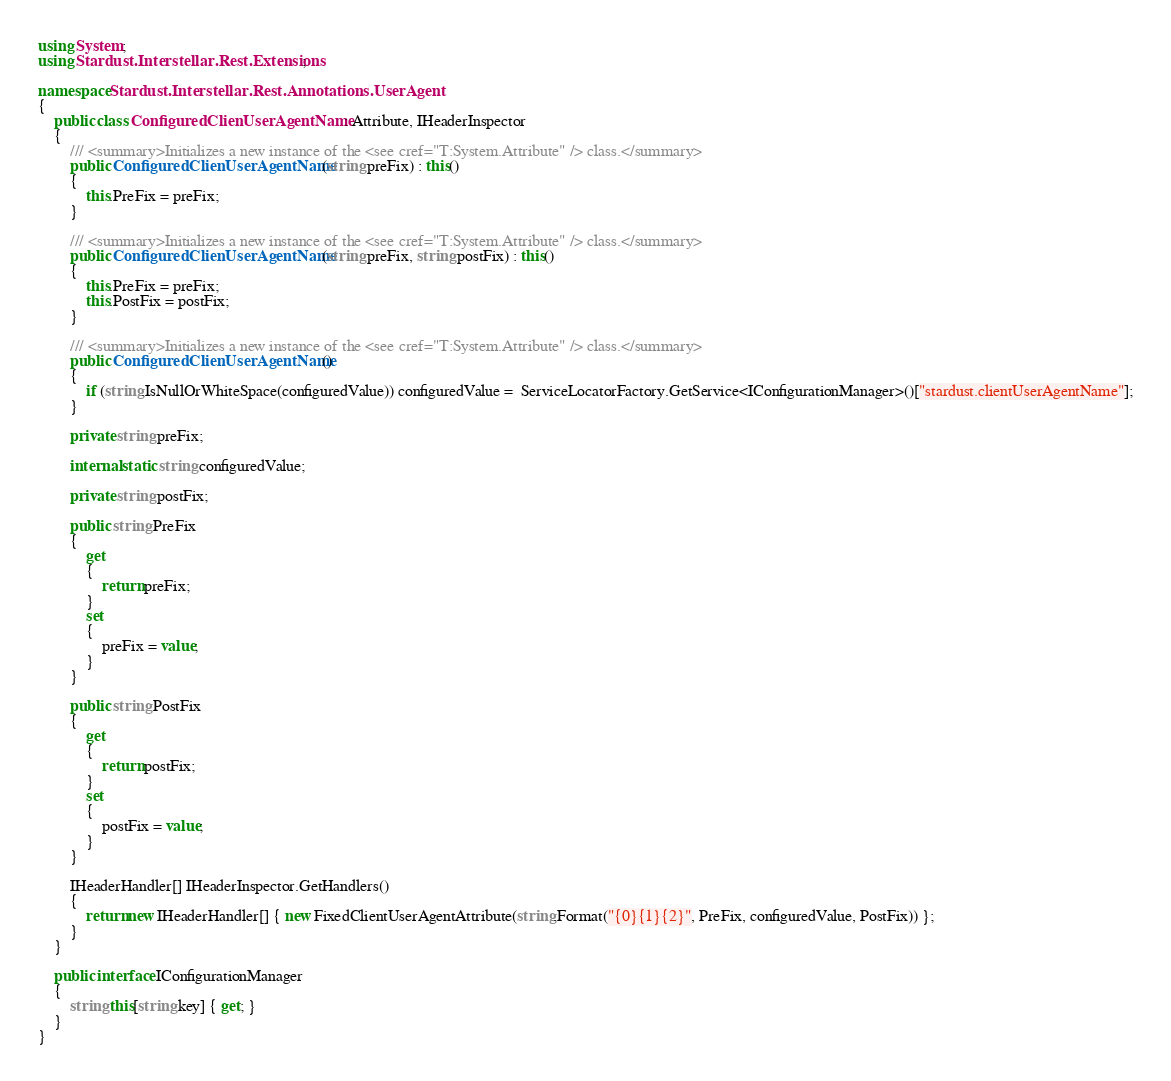<code> <loc_0><loc_0><loc_500><loc_500><_C#_>using System;
using Stardust.Interstellar.Rest.Extensions;

namespace Stardust.Interstellar.Rest.Annotations.UserAgent
{
    public class ConfiguredClienUserAgentName : Attribute, IHeaderInspector
    {
        /// <summary>Initializes a new instance of the <see cref="T:System.Attribute" /> class.</summary>
        public ConfiguredClienUserAgentName(string preFix) : this()
        {
            this.PreFix = preFix;
        }

        /// <summary>Initializes a new instance of the <see cref="T:System.Attribute" /> class.</summary>
        public ConfiguredClienUserAgentName(string preFix, string postFix) : this()
        {
            this.PreFix = preFix;
            this.PostFix = postFix;
        }

        /// <summary>Initializes a new instance of the <see cref="T:System.Attribute" /> class.</summary>
        public ConfiguredClienUserAgentName()
        {
            if (string.IsNullOrWhiteSpace(configuredValue)) configuredValue =  ServiceLocatorFactory.GetService<IConfigurationManager>()["stardust.clientUserAgentName"];
        }

        private string preFix;

        internal static string configuredValue;

        private string postFix;

        public string PreFix
        {
            get
            {
                return preFix;
            }
            set
            {
                preFix = value;
            }
        }

        public string PostFix
        {
            get
            {
                return postFix;
            }
            set
            {
                postFix = value;
            }
        }

        IHeaderHandler[] IHeaderInspector.GetHandlers()
        {
            return new IHeaderHandler[] { new FixedClientUserAgentAttribute(string.Format("{0}{1}{2}", PreFix, configuredValue, PostFix)) };
        }
    }

    public interface IConfigurationManager
    {
        string this[string key] { get; }
    }
}</code> 